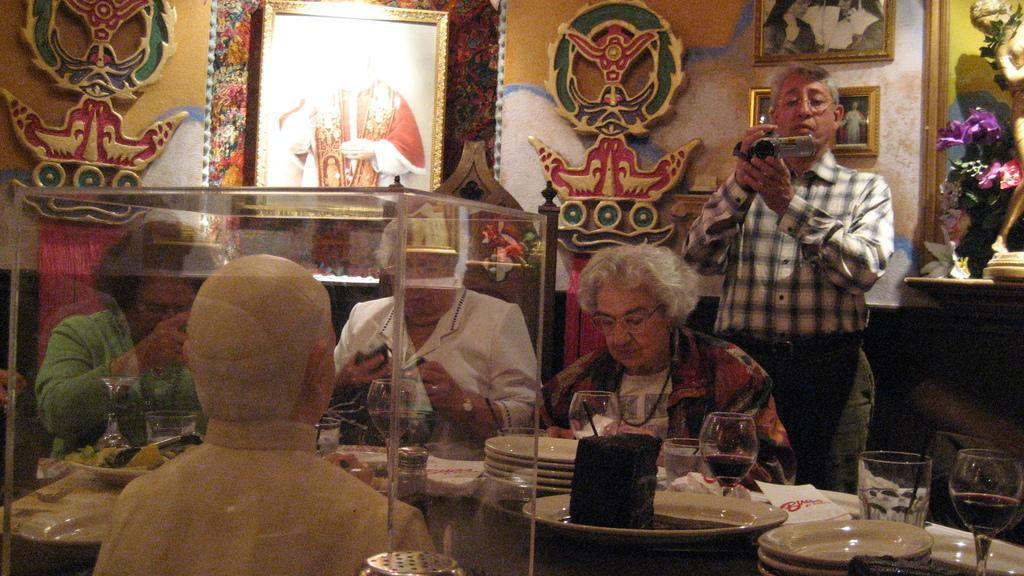In one or two sentences, can you explain what this image depicts? In this image there is a table on which there are plates,glasses,tissue papers and some food on it. On the left side there is a sculpture which is covered with the glass. On the left side there is a person who is standing beside the people who are eating by siting in the chairs. In the background there is a wall on which there are photo frames and some design art on it. The man on the left side is holding the camera. On the right side top there is a sculpture beside the flower vase. 